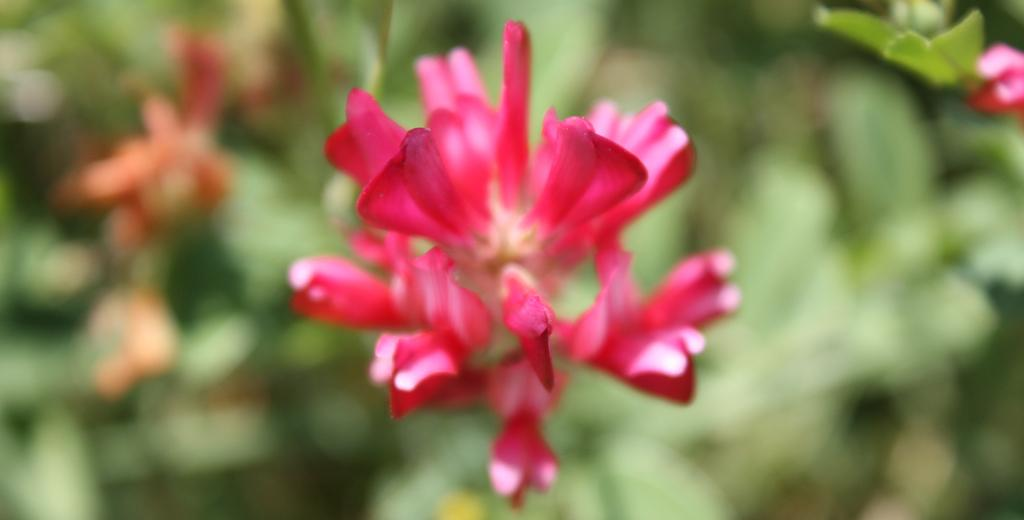What type of flower is in the image? There is a pink color flower in the image. What color is the background of the image? The background of the image is green. What type of argument is taking place in the image? There is no argument present in the image; it features a pink color flower with a green background. What scale is used to measure the size of the flower in the image? There is no scale present in the image to measure the size of the flower. 